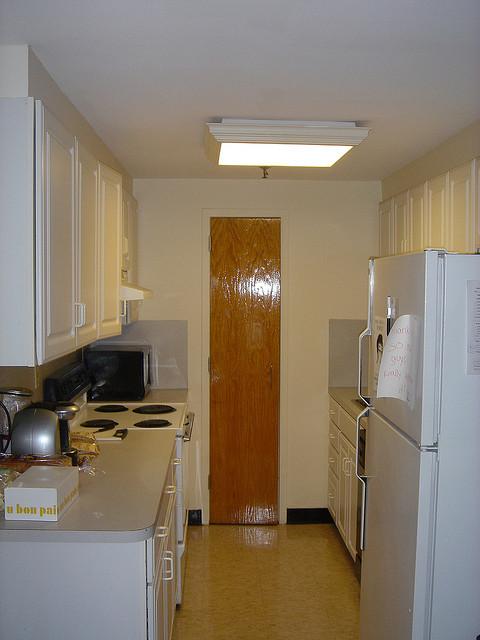Is there anything on the refrigerator?
Concise answer only. Yes. Is this a LED television?
Be succinct. No. What color are the walls?
Be succinct. White. What shape is the ceiling light?
Write a very short answer. Square. Are the curtains long or short?
Give a very brief answer. No curtains. How many lights are there?
Give a very brief answer. 1. Is this kitchen larger than most kitchens?
Be succinct. No. What kind of floor are there?
Answer briefly. Tile. What room is photographed of the home?
Keep it brief. Kitchen. How many ovens are in this kitchen?
Give a very brief answer. 1. Is the door open?
Write a very short answer. No. What color are the floor tiles?
Quick response, please. Yellow. Is that an average sized door?
Give a very brief answer. No. Is the stove electric?
Quick response, please. Yes. Is this room carpeted?
Keep it brief. No. What is on the floor?
Short answer required. Tile. Is there a window in the back door?
Be succinct. No. How many kitchen appliances are featured in this picture?
Answer briefly. 4. What room is this?
Keep it brief. Kitchen. Is the countertop the same color as the cabinets?
Give a very brief answer. Yes. Is the door closed?
Concise answer only. Yes. 